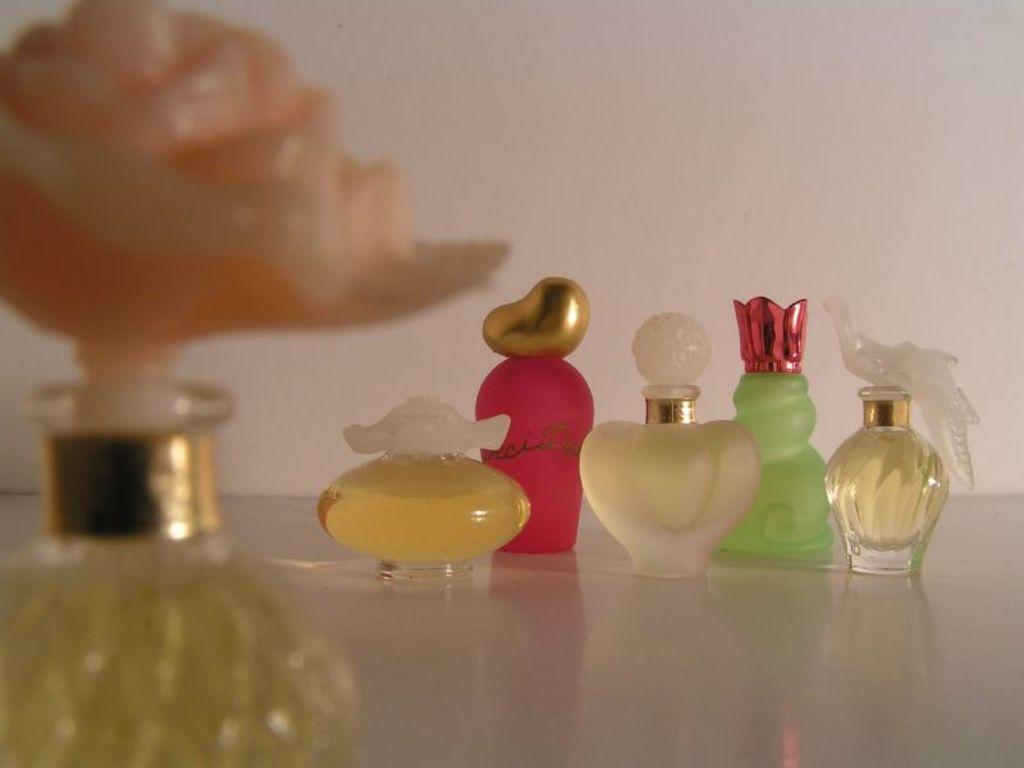What objects are present in the image? There are perfume bottles in the image. How can the perfume bottles be differentiated from one another? The perfume bottles have different colors and shapes. What is the surface on which the perfume bottles are placed? The perfume bottles are on a white surface. What can be seen in the background of the image? There is a wall visible in the image. What is the color of the wall? The wall is white in color. What type of yarn is being used to create the slip in the image? There is no slip or yarn present in the image; it features perfume bottles on a white surface with a white wall in the background. 